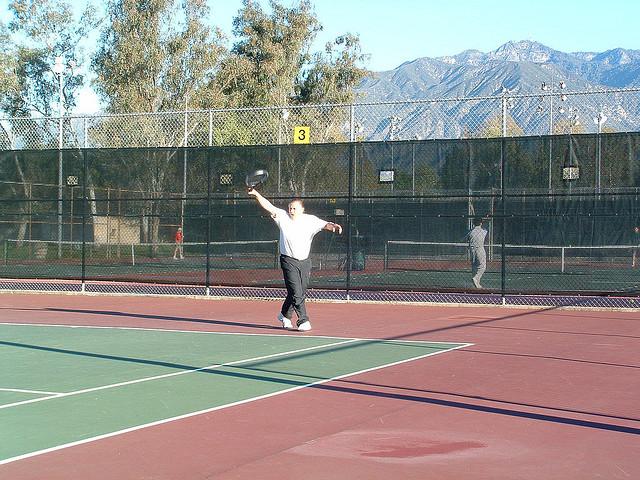What is the color of the fence?
Answer briefly. Green. What sport is he playing?
Give a very brief answer. Tennis. Are they playing near the mountains?
Answer briefly. Yes. 